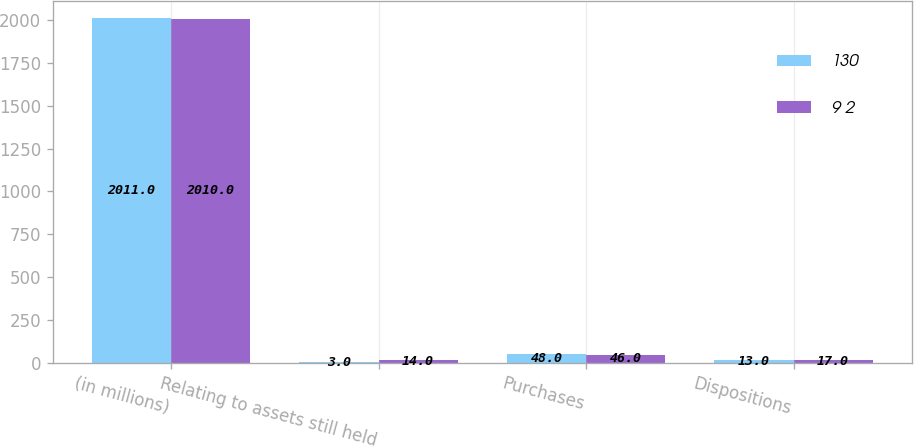Convert chart to OTSL. <chart><loc_0><loc_0><loc_500><loc_500><stacked_bar_chart><ecel><fcel>(in millions)<fcel>Relating to assets still held<fcel>Purchases<fcel>Dispositions<nl><fcel>130<fcel>2011<fcel>3<fcel>48<fcel>13<nl><fcel>9 2<fcel>2010<fcel>14<fcel>46<fcel>17<nl></chart> 